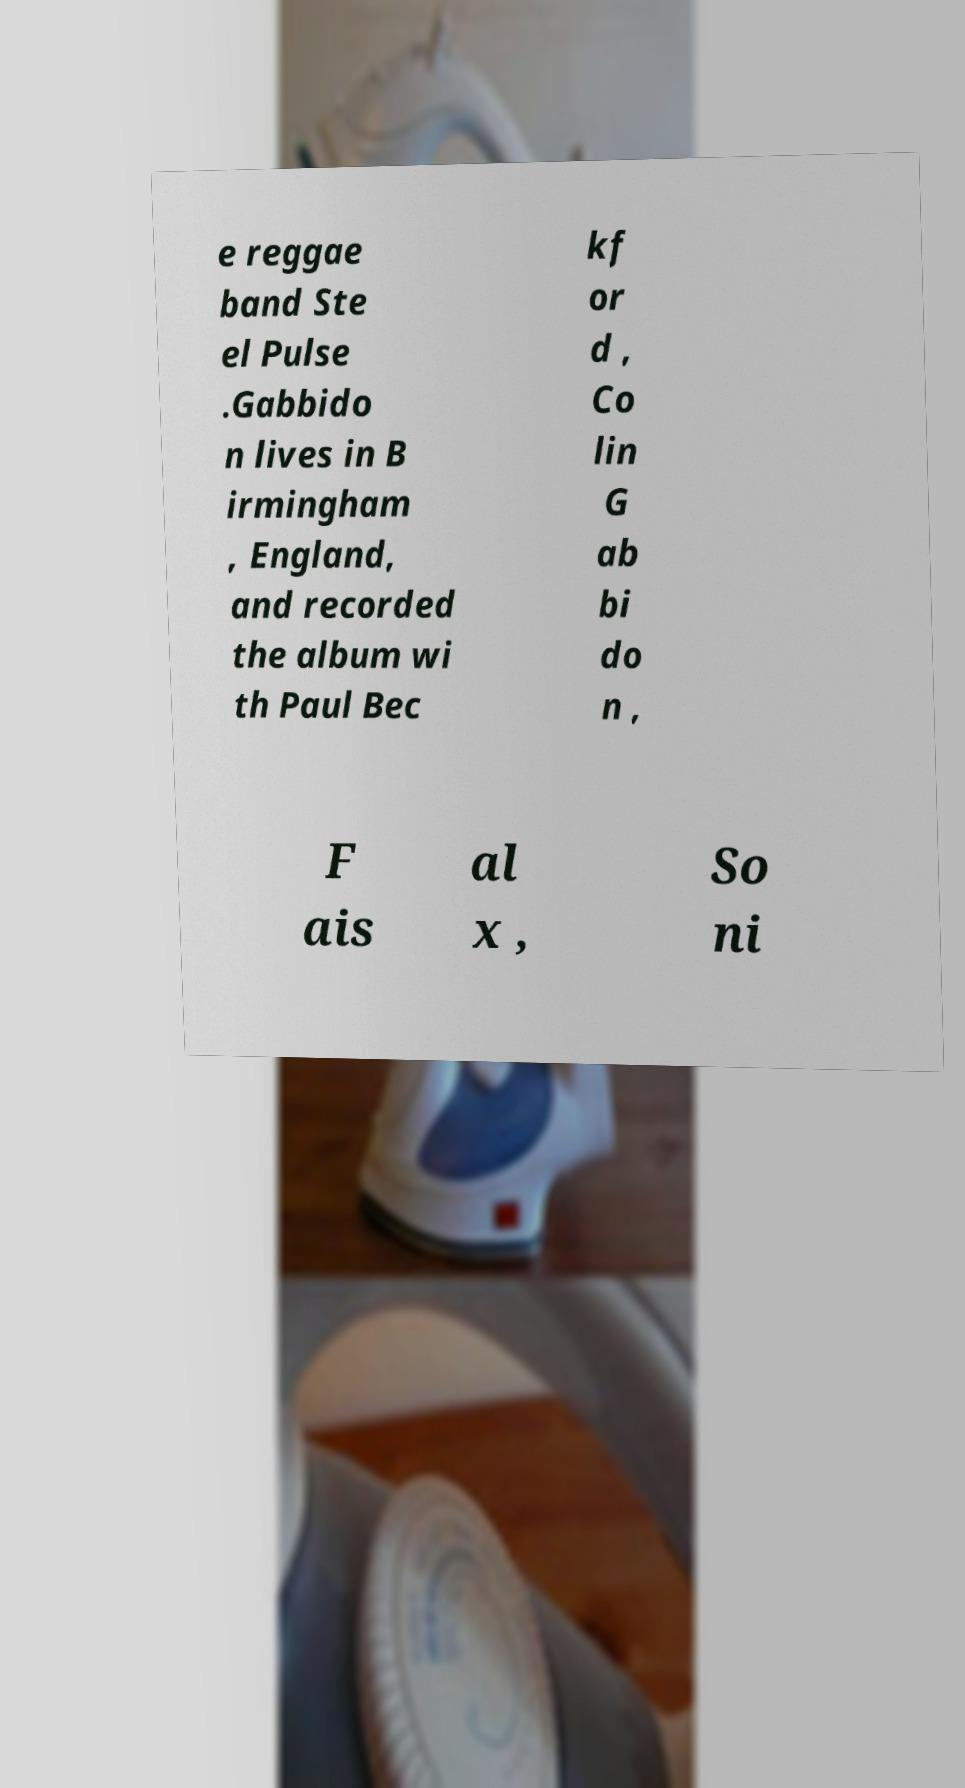What messages or text are displayed in this image? I need them in a readable, typed format. e reggae band Ste el Pulse .Gabbido n lives in B irmingham , England, and recorded the album wi th Paul Bec kf or d , Co lin G ab bi do n , F ais al x , So ni 